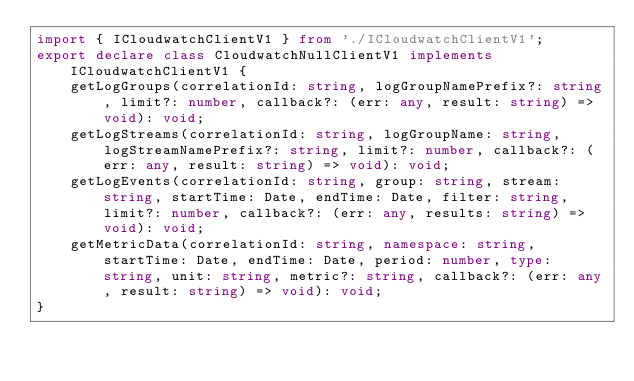<code> <loc_0><loc_0><loc_500><loc_500><_TypeScript_>import { ICloudwatchClientV1 } from './ICloudwatchClientV1';
export declare class CloudwatchNullClientV1 implements ICloudwatchClientV1 {
    getLogGroups(correlationId: string, logGroupNamePrefix?: string, limit?: number, callback?: (err: any, result: string) => void): void;
    getLogStreams(correlationId: string, logGroupName: string, logStreamNamePrefix?: string, limit?: number, callback?: (err: any, result: string) => void): void;
    getLogEvents(correlationId: string, group: string, stream: string, startTime: Date, endTime: Date, filter: string, limit?: number, callback?: (err: any, results: string) => void): void;
    getMetricData(correlationId: string, namespace: string, startTime: Date, endTime: Date, period: number, type: string, unit: string, metric?: string, callback?: (err: any, result: string) => void): void;
}
</code> 